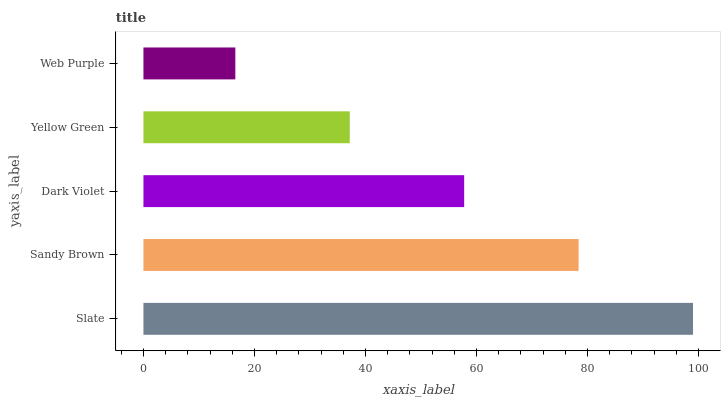Is Web Purple the minimum?
Answer yes or no. Yes. Is Slate the maximum?
Answer yes or no. Yes. Is Sandy Brown the minimum?
Answer yes or no. No. Is Sandy Brown the maximum?
Answer yes or no. No. Is Slate greater than Sandy Brown?
Answer yes or no. Yes. Is Sandy Brown less than Slate?
Answer yes or no. Yes. Is Sandy Brown greater than Slate?
Answer yes or no. No. Is Slate less than Sandy Brown?
Answer yes or no. No. Is Dark Violet the high median?
Answer yes or no. Yes. Is Dark Violet the low median?
Answer yes or no. Yes. Is Slate the high median?
Answer yes or no. No. Is Slate the low median?
Answer yes or no. No. 